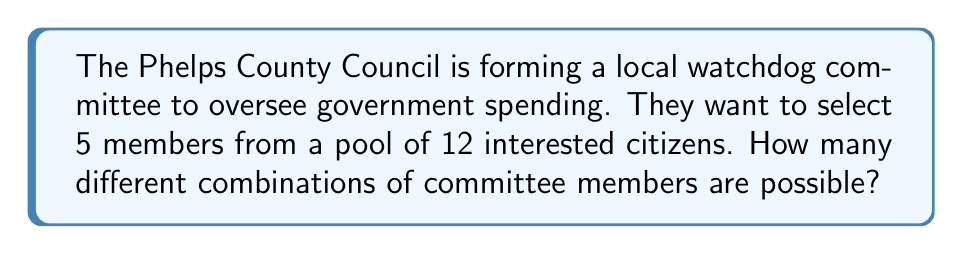Help me with this question. Let's approach this step-by-step:

1) This is a combination problem because the order of selection doesn't matter (it's the same committee regardless of the order in which members are chosen).

2) We're selecting 5 people from a group of 12.

3) The formula for combinations is:

   $$C(n,r) = \frac{n!}{r!(n-r)!}$$

   Where $n$ is the total number of items to choose from, and $r$ is the number of items being chosen.

4) In this case, $n = 12$ and $r = 5$

5) Plugging these values into our formula:

   $$C(12,5) = \frac{12!}{5!(12-5)!} = \frac{12!}{5!7!}$$

6) Expanding this:
   
   $$\frac{12 \cdot 11 \cdot 10 \cdot 9 \cdot 8 \cdot 7!}{(5 \cdot 4 \cdot 3 \cdot 2 \cdot 1) \cdot 7!}$$

7) The 7! cancels out in the numerator and denominator:

   $$\frac{12 \cdot 11 \cdot 10 \cdot 9 \cdot 8}{5 \cdot 4 \cdot 3 \cdot 2 \cdot 1} = \frac{95040}{120} = 792$$

Therefore, there are 792 possible combinations for the watchdog committee.
Answer: 792 